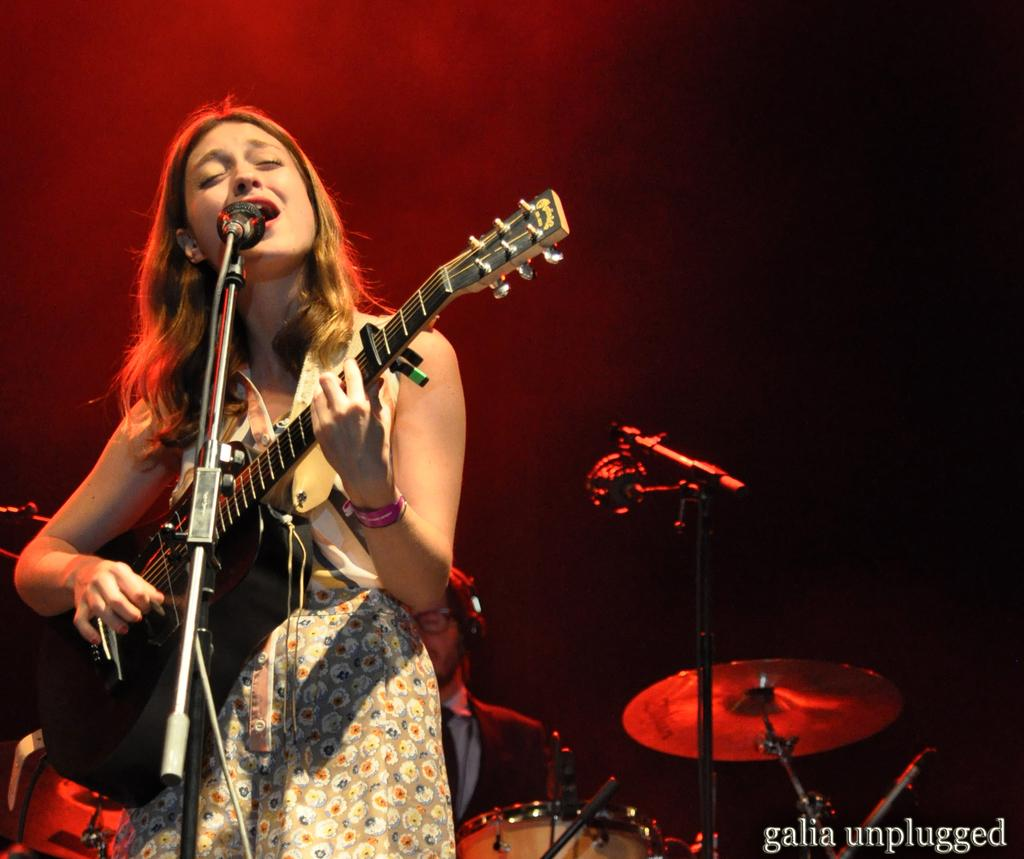Who is the main subject in the image? The main subject in the image is a lady. What is the lady holding in the image? The lady is holding a guitar in the image. What is the lady doing with the guitar? The lady is playing the guitar in the image. What object is in front of the lady? There is a microphone in front of the lady in the image. Who else is present in the image? There is a man in the image. What is the man doing in the image? The man is playing a musical instrument in the image. Where is the park located in the image? There is no park present in the image. Can you tell me how much the receipt costs in the image? There is no receipt present in the image. 